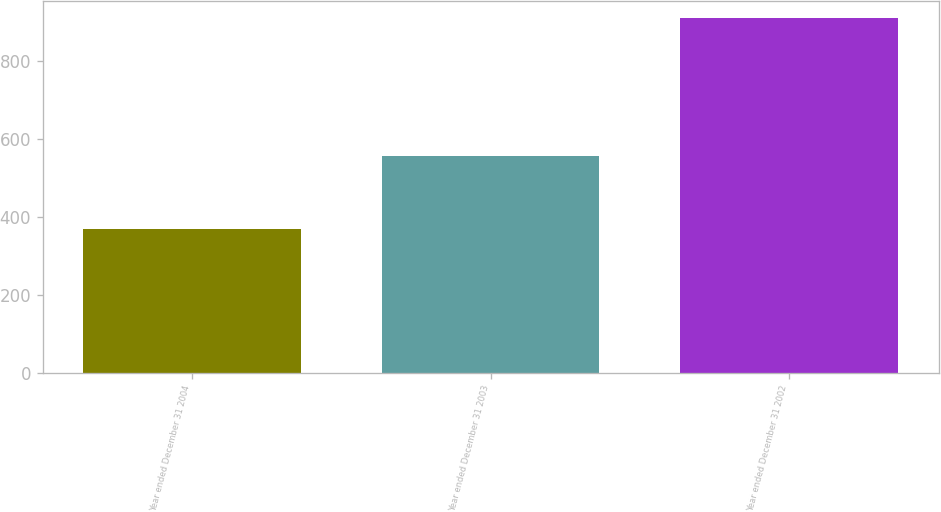<chart> <loc_0><loc_0><loc_500><loc_500><bar_chart><fcel>Year ended December 31 2004<fcel>Year ended December 31 2003<fcel>Year ended December 31 2002<nl><fcel>368<fcel>557<fcel>909<nl></chart> 